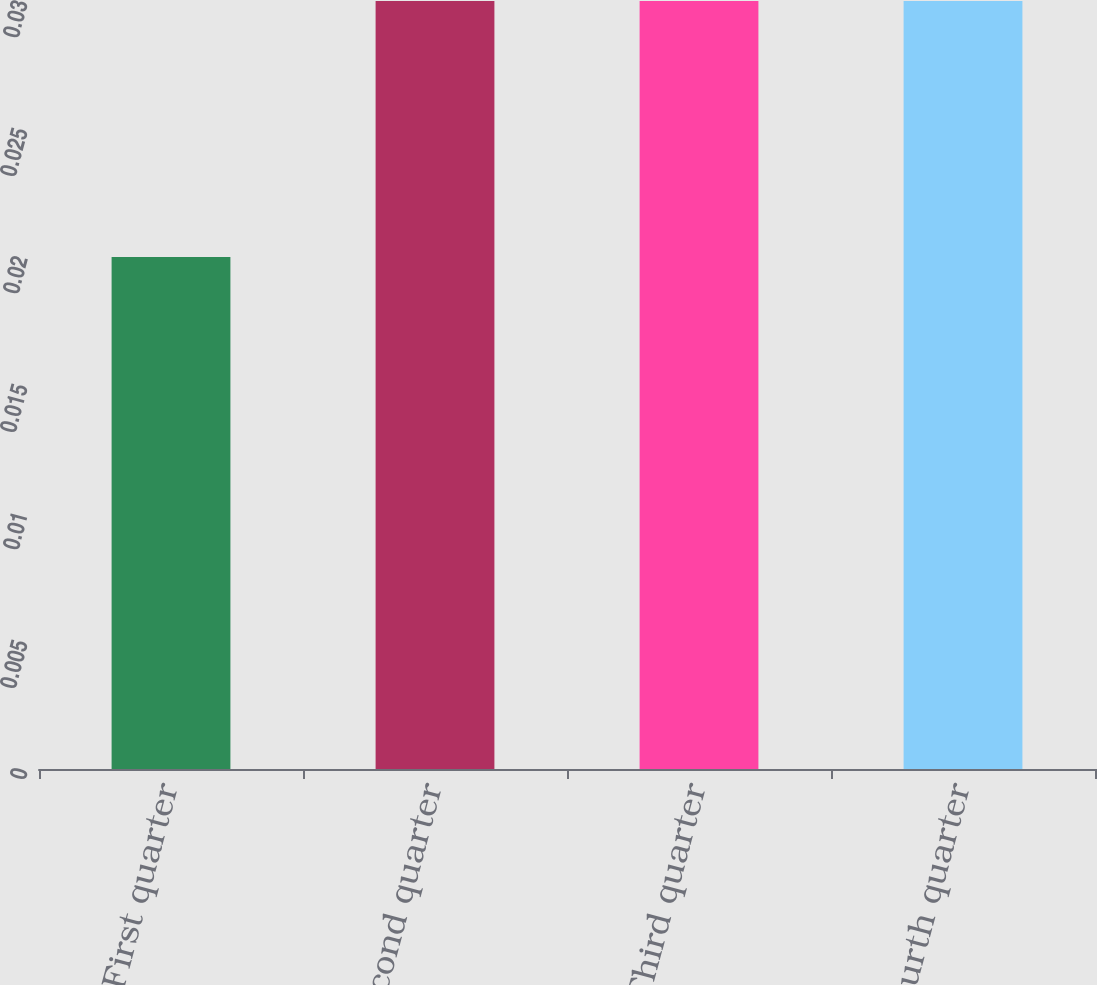Convert chart to OTSL. <chart><loc_0><loc_0><loc_500><loc_500><bar_chart><fcel>First quarter<fcel>Second quarter<fcel>Third quarter<fcel>Fourth quarter<nl><fcel>0.02<fcel>0.03<fcel>0.03<fcel>0.03<nl></chart> 